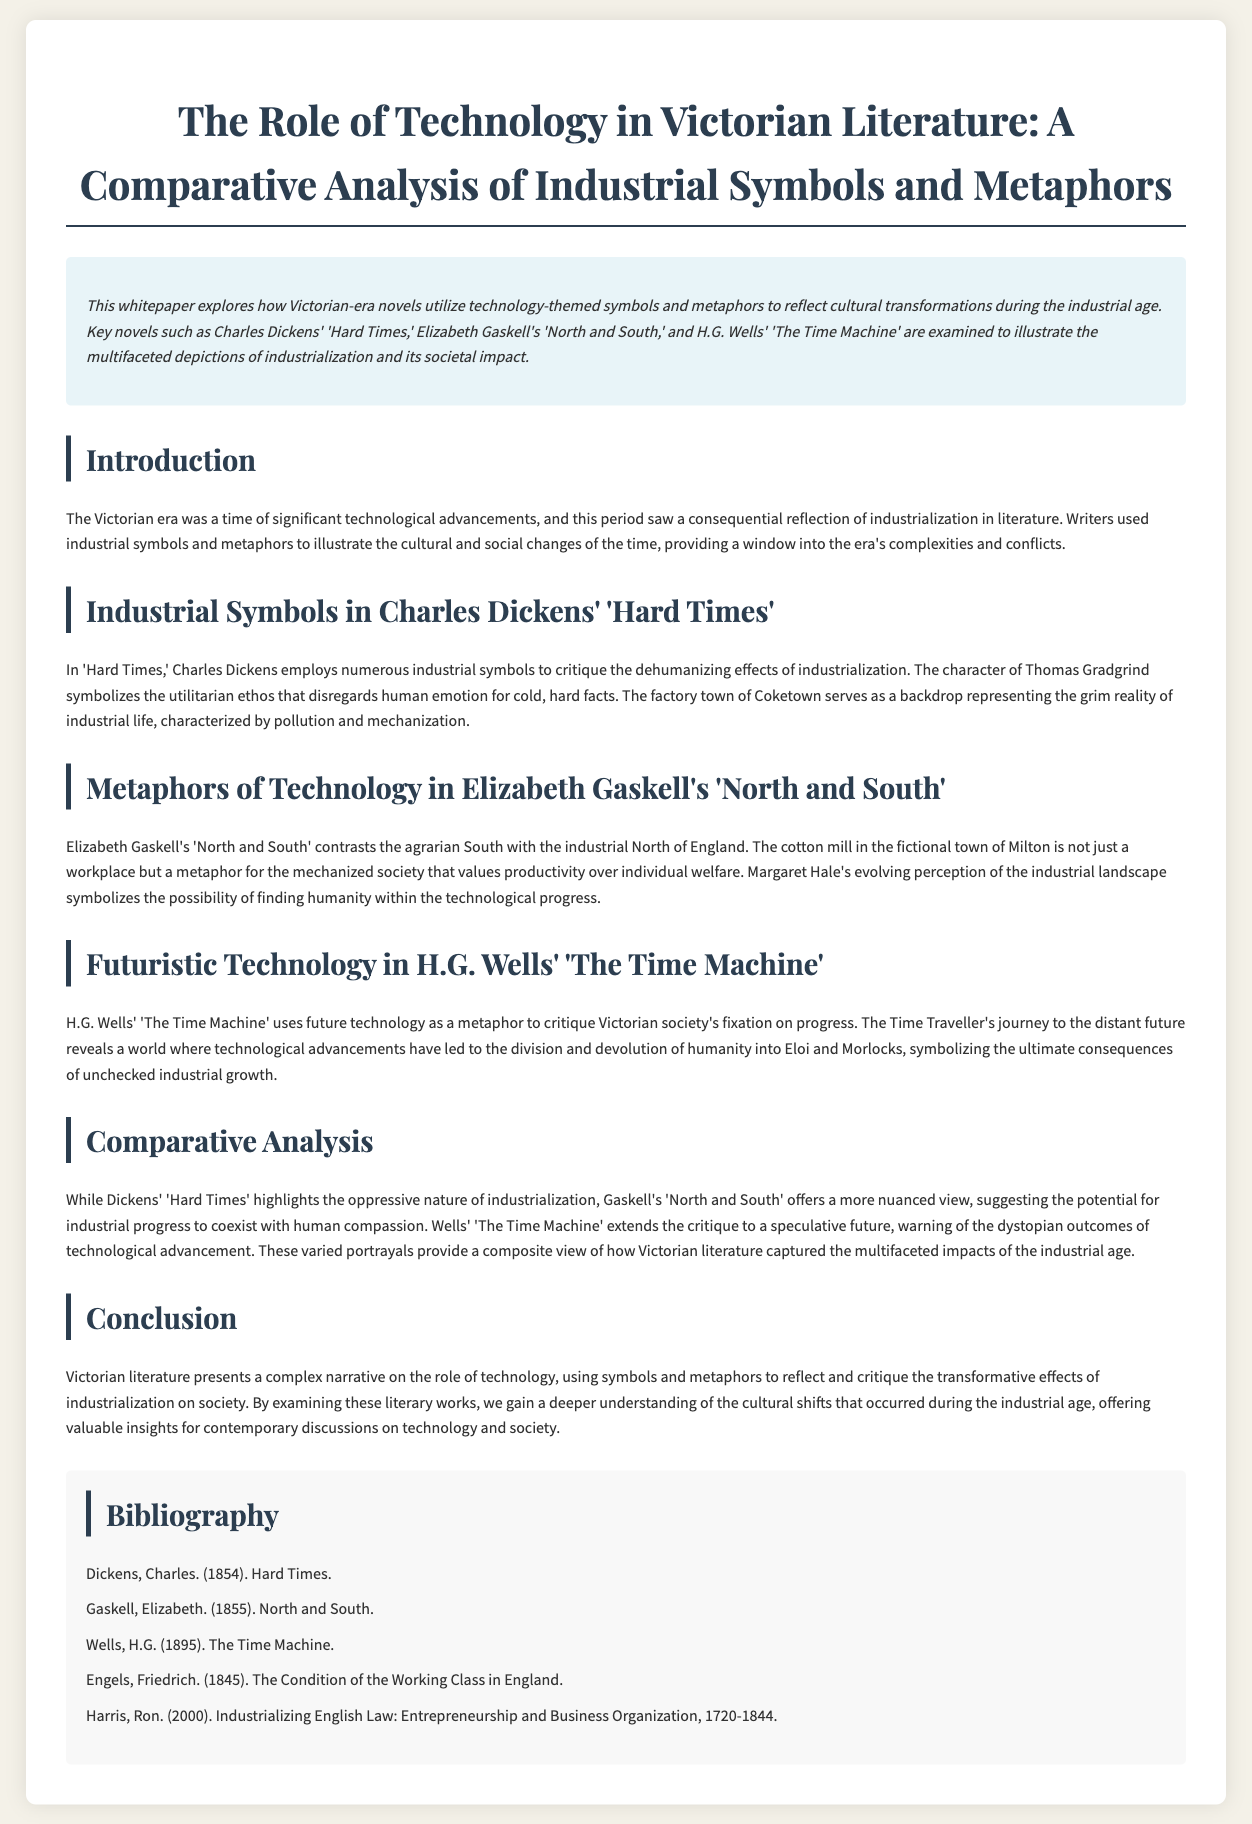What key novels are examined in the whitepaper? The abstract mentions three key novels that illustrate industrialization and its societal impact.
Answer: 'Hard Times,' 'North and South,' 'The Time Machine' Who is the author of 'Hard Times'? The bibliography lists the authors of the novels discussed, including the author of 'Hard Times.'
Answer: Charles Dickens What is the main symbol representing the grim reality of industrial life in 'Hard Times'? The section on Dickens' work identifies a specific setting that symbolizes industrial life.
Answer: Coketown Which character in 'North and South' symbolizes the potential for humanity within technological progress? The section on Gaskell's novel highlights a character representing this idea.
Answer: Margaret Hale What does the Time Traveller's journey in 'The Time Machine' critique? The section on Wells' work describes what the Time Traveller's experiences reveal about society.
Answer: Victorian society's fixation on progress How does Gaskell's view of industrialization differ from Dickens' in their respective novels? The comparative analysis section discusses the contrast in perspectives on industrialization between the two authors.
Answer: Nuanced view vs. oppressive nature What is the purpose of the whitepaper? The introduction outlines the main goal of the whitepaper regarding Victorian literature.
Answer: To explore how literature reflects cultural transformations during the industrial age In what year was 'The Time Machine' published? The bibliography provides publication years for the novels mentioned in the whitepaper.
Answer: 1895 What does the conclusion suggest about the role of technology in Victorian literature? The conclusion summarizes the insights gained about technology's cultural impact as depicted in the literature.
Answer: Reflect and critique transformative effects of industrialization 